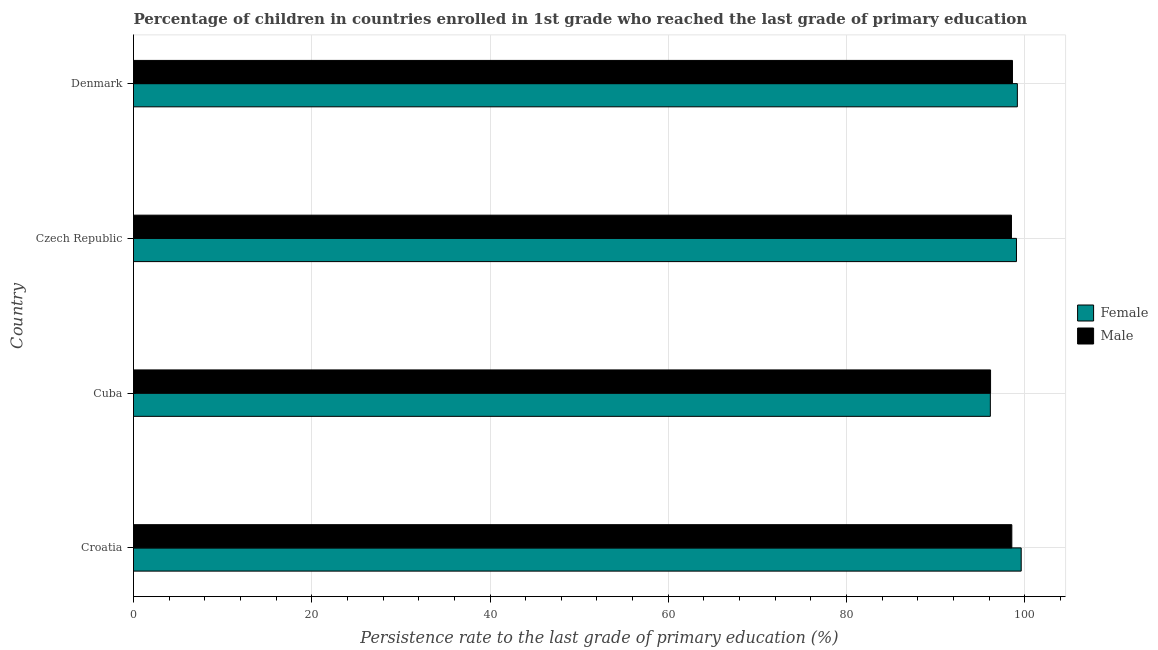How many different coloured bars are there?
Offer a terse response. 2. How many groups of bars are there?
Your answer should be compact. 4. How many bars are there on the 2nd tick from the top?
Your response must be concise. 2. How many bars are there on the 1st tick from the bottom?
Provide a short and direct response. 2. What is the label of the 3rd group of bars from the top?
Your answer should be very brief. Cuba. In how many cases, is the number of bars for a given country not equal to the number of legend labels?
Keep it short and to the point. 0. What is the persistence rate of male students in Czech Republic?
Your answer should be very brief. 98.51. Across all countries, what is the maximum persistence rate of female students?
Your response must be concise. 99.6. Across all countries, what is the minimum persistence rate of male students?
Ensure brevity in your answer.  96.16. In which country was the persistence rate of female students maximum?
Give a very brief answer. Croatia. In which country was the persistence rate of male students minimum?
Give a very brief answer. Cuba. What is the total persistence rate of female students in the graph?
Offer a terse response. 393.98. What is the difference between the persistence rate of male students in Cuba and that in Denmark?
Provide a short and direct response. -2.46. What is the difference between the persistence rate of female students in Czech Republic and the persistence rate of male students in Cuba?
Provide a short and direct response. 2.91. What is the average persistence rate of male students per country?
Your answer should be very brief. 97.96. What is the difference between the persistence rate of male students and persistence rate of female students in Czech Republic?
Your answer should be compact. -0.56. In how many countries, is the persistence rate of male students greater than 28 %?
Your answer should be very brief. 4. Is the persistence rate of female students in Croatia less than that in Denmark?
Your response must be concise. No. What is the difference between the highest and the second highest persistence rate of female students?
Ensure brevity in your answer.  0.43. What is the difference between the highest and the lowest persistence rate of female students?
Keep it short and to the point. 3.46. Is the sum of the persistence rate of female students in Cuba and Czech Republic greater than the maximum persistence rate of male students across all countries?
Offer a very short reply. Yes. Are all the bars in the graph horizontal?
Your answer should be very brief. Yes. How many countries are there in the graph?
Offer a very short reply. 4. Are the values on the major ticks of X-axis written in scientific E-notation?
Provide a succinct answer. No. Does the graph contain grids?
Provide a succinct answer. Yes. How many legend labels are there?
Give a very brief answer. 2. How are the legend labels stacked?
Provide a short and direct response. Vertical. What is the title of the graph?
Offer a very short reply. Percentage of children in countries enrolled in 1st grade who reached the last grade of primary education. Does "Chemicals" appear as one of the legend labels in the graph?
Make the answer very short. No. What is the label or title of the X-axis?
Give a very brief answer. Persistence rate to the last grade of primary education (%). What is the label or title of the Y-axis?
Make the answer very short. Country. What is the Persistence rate to the last grade of primary education (%) in Female in Croatia?
Your response must be concise. 99.6. What is the Persistence rate to the last grade of primary education (%) of Male in Croatia?
Your answer should be very brief. 98.55. What is the Persistence rate to the last grade of primary education (%) in Female in Cuba?
Provide a succinct answer. 96.14. What is the Persistence rate to the last grade of primary education (%) of Male in Cuba?
Make the answer very short. 96.16. What is the Persistence rate to the last grade of primary education (%) in Female in Czech Republic?
Offer a terse response. 99.07. What is the Persistence rate to the last grade of primary education (%) of Male in Czech Republic?
Give a very brief answer. 98.51. What is the Persistence rate to the last grade of primary education (%) of Female in Denmark?
Provide a succinct answer. 99.17. What is the Persistence rate to the last grade of primary education (%) in Male in Denmark?
Your response must be concise. 98.62. Across all countries, what is the maximum Persistence rate to the last grade of primary education (%) of Female?
Ensure brevity in your answer.  99.6. Across all countries, what is the maximum Persistence rate to the last grade of primary education (%) in Male?
Give a very brief answer. 98.62. Across all countries, what is the minimum Persistence rate to the last grade of primary education (%) in Female?
Provide a short and direct response. 96.14. Across all countries, what is the minimum Persistence rate to the last grade of primary education (%) in Male?
Your response must be concise. 96.16. What is the total Persistence rate to the last grade of primary education (%) of Female in the graph?
Provide a succinct answer. 393.98. What is the total Persistence rate to the last grade of primary education (%) of Male in the graph?
Your response must be concise. 391.84. What is the difference between the Persistence rate to the last grade of primary education (%) of Female in Croatia and that in Cuba?
Make the answer very short. 3.46. What is the difference between the Persistence rate to the last grade of primary education (%) in Male in Croatia and that in Cuba?
Your answer should be compact. 2.39. What is the difference between the Persistence rate to the last grade of primary education (%) in Female in Croatia and that in Czech Republic?
Ensure brevity in your answer.  0.53. What is the difference between the Persistence rate to the last grade of primary education (%) in Male in Croatia and that in Czech Republic?
Keep it short and to the point. 0.04. What is the difference between the Persistence rate to the last grade of primary education (%) in Female in Croatia and that in Denmark?
Give a very brief answer. 0.43. What is the difference between the Persistence rate to the last grade of primary education (%) of Male in Croatia and that in Denmark?
Your answer should be very brief. -0.07. What is the difference between the Persistence rate to the last grade of primary education (%) of Female in Cuba and that in Czech Republic?
Your response must be concise. -2.93. What is the difference between the Persistence rate to the last grade of primary education (%) of Male in Cuba and that in Czech Republic?
Provide a succinct answer. -2.35. What is the difference between the Persistence rate to the last grade of primary education (%) in Female in Cuba and that in Denmark?
Ensure brevity in your answer.  -3.03. What is the difference between the Persistence rate to the last grade of primary education (%) of Male in Cuba and that in Denmark?
Make the answer very short. -2.46. What is the difference between the Persistence rate to the last grade of primary education (%) of Female in Czech Republic and that in Denmark?
Your response must be concise. -0.1. What is the difference between the Persistence rate to the last grade of primary education (%) of Male in Czech Republic and that in Denmark?
Give a very brief answer. -0.11. What is the difference between the Persistence rate to the last grade of primary education (%) in Female in Croatia and the Persistence rate to the last grade of primary education (%) in Male in Cuba?
Your answer should be very brief. 3.44. What is the difference between the Persistence rate to the last grade of primary education (%) in Female in Croatia and the Persistence rate to the last grade of primary education (%) in Male in Czech Republic?
Offer a terse response. 1.09. What is the difference between the Persistence rate to the last grade of primary education (%) of Female in Croatia and the Persistence rate to the last grade of primary education (%) of Male in Denmark?
Your answer should be very brief. 0.98. What is the difference between the Persistence rate to the last grade of primary education (%) in Female in Cuba and the Persistence rate to the last grade of primary education (%) in Male in Czech Republic?
Provide a short and direct response. -2.37. What is the difference between the Persistence rate to the last grade of primary education (%) of Female in Cuba and the Persistence rate to the last grade of primary education (%) of Male in Denmark?
Your answer should be compact. -2.48. What is the difference between the Persistence rate to the last grade of primary education (%) of Female in Czech Republic and the Persistence rate to the last grade of primary education (%) of Male in Denmark?
Your answer should be compact. 0.45. What is the average Persistence rate to the last grade of primary education (%) of Female per country?
Keep it short and to the point. 98.49. What is the average Persistence rate to the last grade of primary education (%) of Male per country?
Your answer should be compact. 97.96. What is the difference between the Persistence rate to the last grade of primary education (%) in Female and Persistence rate to the last grade of primary education (%) in Male in Croatia?
Make the answer very short. 1.05. What is the difference between the Persistence rate to the last grade of primary education (%) in Female and Persistence rate to the last grade of primary education (%) in Male in Cuba?
Offer a terse response. -0.02. What is the difference between the Persistence rate to the last grade of primary education (%) in Female and Persistence rate to the last grade of primary education (%) in Male in Czech Republic?
Give a very brief answer. 0.56. What is the difference between the Persistence rate to the last grade of primary education (%) of Female and Persistence rate to the last grade of primary education (%) of Male in Denmark?
Your answer should be compact. 0.55. What is the ratio of the Persistence rate to the last grade of primary education (%) in Female in Croatia to that in Cuba?
Provide a succinct answer. 1.04. What is the ratio of the Persistence rate to the last grade of primary education (%) of Male in Croatia to that in Cuba?
Ensure brevity in your answer.  1.02. What is the ratio of the Persistence rate to the last grade of primary education (%) in Female in Croatia to that in Czech Republic?
Offer a very short reply. 1.01. What is the ratio of the Persistence rate to the last grade of primary education (%) in Female in Croatia to that in Denmark?
Your answer should be compact. 1. What is the ratio of the Persistence rate to the last grade of primary education (%) in Male in Croatia to that in Denmark?
Make the answer very short. 1. What is the ratio of the Persistence rate to the last grade of primary education (%) in Female in Cuba to that in Czech Republic?
Your response must be concise. 0.97. What is the ratio of the Persistence rate to the last grade of primary education (%) of Male in Cuba to that in Czech Republic?
Your answer should be compact. 0.98. What is the ratio of the Persistence rate to the last grade of primary education (%) in Female in Cuba to that in Denmark?
Your response must be concise. 0.97. What is the ratio of the Persistence rate to the last grade of primary education (%) in Male in Cuba to that in Denmark?
Ensure brevity in your answer.  0.98. What is the difference between the highest and the second highest Persistence rate to the last grade of primary education (%) of Female?
Give a very brief answer. 0.43. What is the difference between the highest and the second highest Persistence rate to the last grade of primary education (%) of Male?
Your answer should be compact. 0.07. What is the difference between the highest and the lowest Persistence rate to the last grade of primary education (%) of Female?
Keep it short and to the point. 3.46. What is the difference between the highest and the lowest Persistence rate to the last grade of primary education (%) of Male?
Provide a succinct answer. 2.46. 